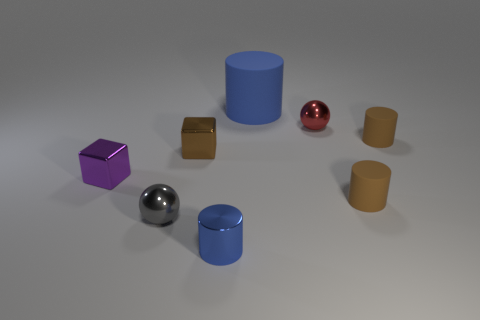What is the size of the other blue thing that is the same shape as the blue rubber thing?
Offer a very short reply. Small. What shape is the small shiny thing that is right of the big blue object?
Your response must be concise. Sphere. Is the shape of the small red object the same as the blue object left of the blue matte cylinder?
Your answer should be very brief. No. Are there an equal number of brown cylinders to the left of the gray metallic sphere and red balls behind the purple thing?
Ensure brevity in your answer.  No. What is the shape of the small object that is the same color as the big object?
Offer a terse response. Cylinder. Is the color of the tiny metallic object in front of the small gray metallic object the same as the large matte object right of the blue shiny object?
Ensure brevity in your answer.  Yes. Is the number of gray metal balls that are in front of the purple cube greater than the number of large green spheres?
Offer a terse response. Yes. What is the big cylinder made of?
Your answer should be compact. Rubber. What is the shape of the tiny red object that is made of the same material as the tiny blue object?
Offer a terse response. Sphere. How big is the blue cylinder behind the small cylinder that is in front of the small gray metal ball?
Keep it short and to the point. Large. 